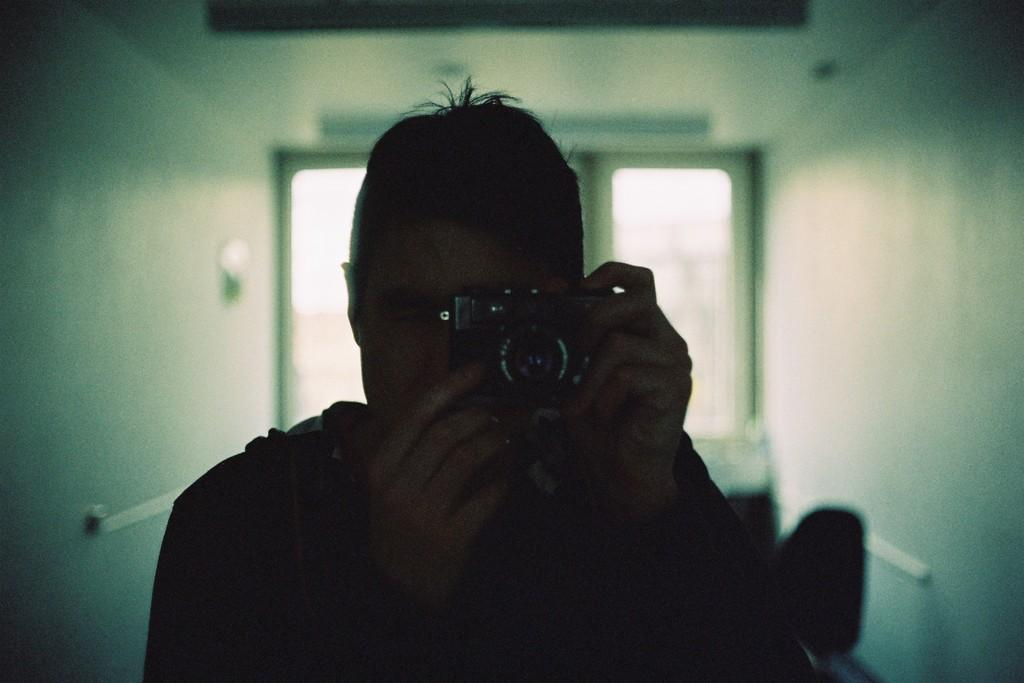What is the main subject of the image? The main subject of the image is a guy. What is the guy holding in the image? The guy is holding a black camera in the image. How is the guy holding the camera? The guy is using both hands to hold the camera in the image. What is the guy doing with the camera? The guy is clicking an image with the camera. What can be seen in the background of the image? There is a glass window in the background of the image. What type of rice can be seen in the image? There is no rice present in the image. How many pears are visible in the image? There are no pears visible in the image. 